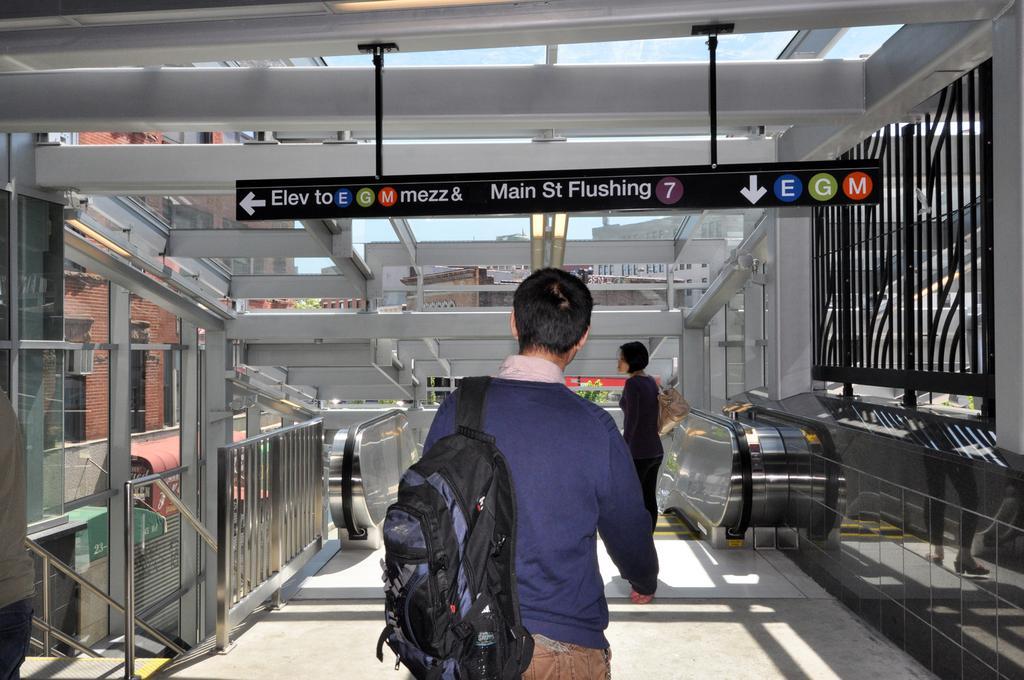Please provide a concise description of this image. One person is wearing a blue jacket and holding a bag moving towards the escalator. One lady is standing near the escalator. And near the escalator there are some railings. In the background there are some buildings and one sign board is changed over the ceiling. There is a grill near the escalator. 